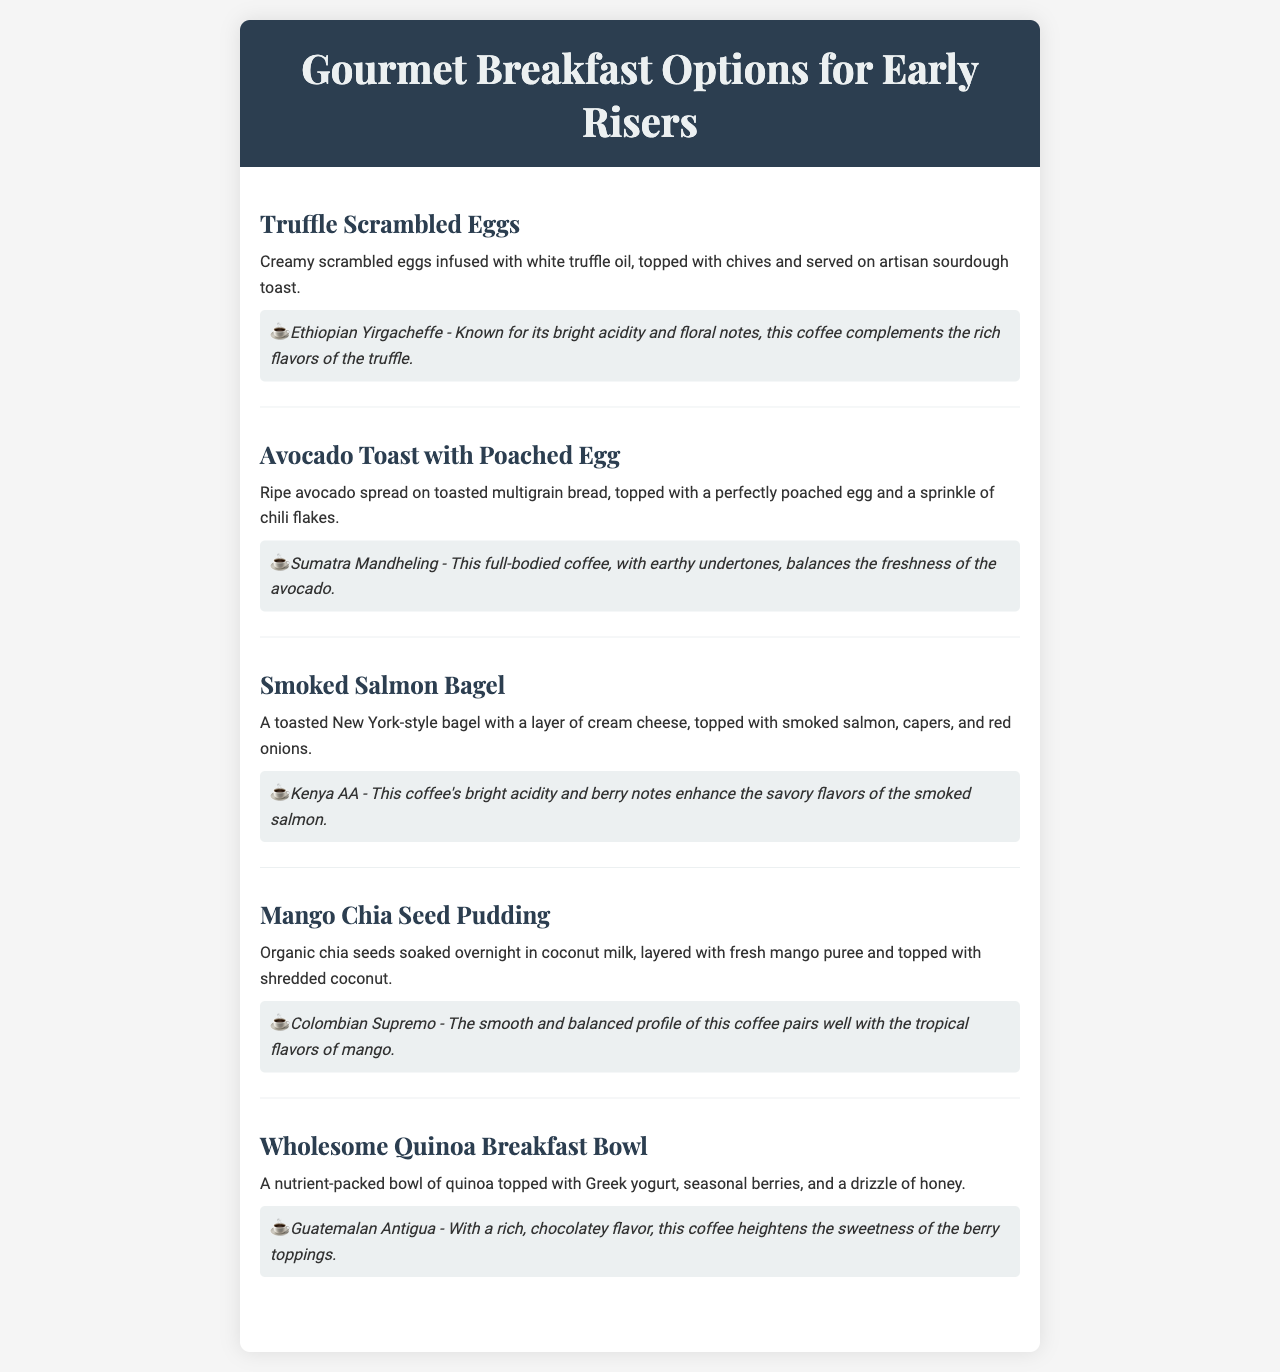What is the first item on the menu? The first menu item listed is "Truffle Scrambled Eggs."
Answer: Truffle Scrambled Eggs What is paired with the Avocado Toast? The coffee pairing for Avocado Toast with Poached Egg is "Sumatra Mandheling."
Answer: Sumatra Mandheling How many breakfast options are listed in the menu? There are a total of five breakfast options mentioned in the menu.
Answer: Five What type of bread is used for the Smoked Salmon Bagel? The Smoked Salmon Bagel is made with a "New York-style bagel."
Answer: New York-style bagel Which coffee enhances the flavors of Mango Chia Seed Pudding? The coffee pairing that enhances the flavors of Mango Chia Seed Pudding is "Colombian Supremo."
Answer: Colombian Supremo What flavor notes are associated with the Kenya AA coffee? Kenya AA coffee is known for its "bright acidity and berry notes."
Answer: Bright acidity and berry notes What ingredient tops the Wholesome Quinoa Breakfast Bowl? The Wholesome Quinoa Breakfast Bowl is topped with "Greek yogurt, seasonal berries, and a drizzle of honey."
Answer: Greek yogurt, seasonal berries, and a drizzle of honey Which breakfast option features chia seeds? The breakfast option that features chia seeds is "Mango Chia Seed Pudding."
Answer: Mango Chia Seed Pudding 